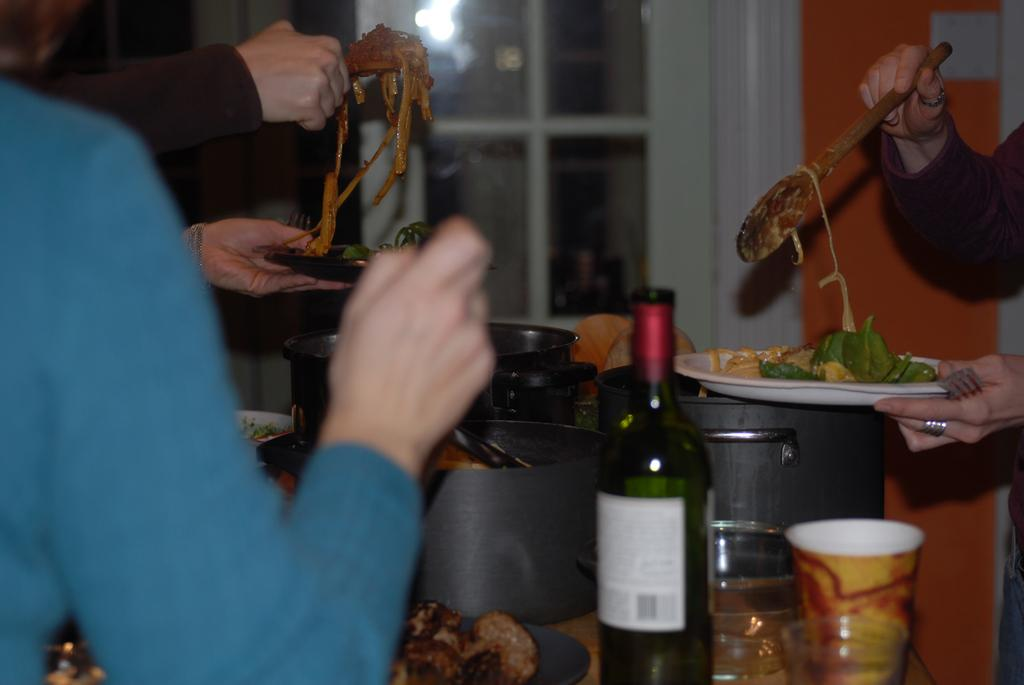How many people are in the image? There are three people in the image. What are the people doing in the image? The people are holding plates and serving food from bowls on tables. What else can be seen on the table in the image? There are glasses and bottles on the table. What type of whip is being used by the person in the image? There is no whip present in the image. Can you tell me how many goats are visible in the image? There are no goats visible in the image. 